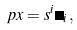<formula> <loc_0><loc_0><loc_500><loc_500>\ p x = s ^ { i } \Pi _ { i } \, ,</formula> 